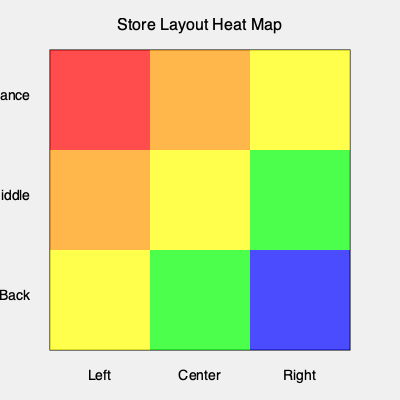Based on the heat map of the store layout, which area shows the highest customer traffic, and what strategy would you recommend to optimize sales in the least trafficked area? To analyze the heat map and develop a strategy, let's follow these steps:

1. Interpret the heat map:
   - Red: Highest traffic
   - Orange: High traffic
   - Yellow: Moderate traffic
   - Green: Low traffic
   - Blue: Lowest traffic

2. Identify the highest traffic area:
   - The top-left corner (entrance-left) is red, indicating the highest customer traffic.

3. Identify the lowest traffic area:
   - The bottom-right corner (back-right) is blue, showing the lowest customer traffic.

4. Analyze traffic patterns:
   - Traffic generally decreases from left to right and front to back.
   - The center and right sections of the entrance area still maintain high traffic.

5. Strategy for optimizing sales in the least trafficked area:
   a) Product placement: Move high-margin or popular items to the back-right section to draw customers.
   b) Visual merchandising: Improve displays and signage in this area to attract attention.
   c) Store layout: Create a path that naturally leads customers to the back-right corner.
   d) Promotions: Offer special discounts or exclusive items in this area to incentivize visits.
   e) Staff engagement: Train staff to guide customers to this section when appropriate.

6. Additional considerations:
   - Use the high-traffic areas (red and orange) for promotional displays or seasonal items.
   - Ensure that the transition between high and low traffic areas is smooth to maintain customer flow.

By implementing these strategies, you can potentially increase foot traffic and sales in the least visited area while maintaining the effectiveness of your high-traffic zones.
Answer: Place high-margin products in back-right, improve displays, create customer path, offer promotions, and train staff to guide customers. 